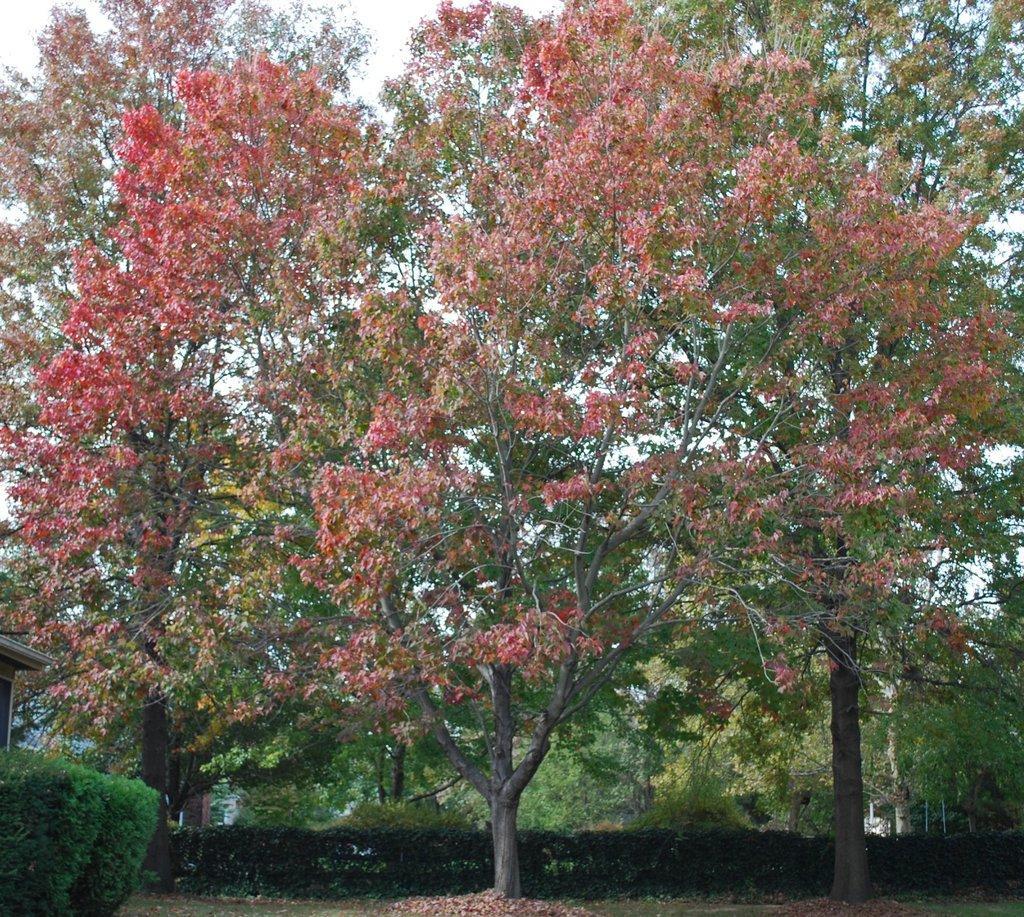Could you give a brief overview of what you see in this image? Here in this picture we can see number of trees and plants and bushes present over there and we can see flowers present on the trees over there. 